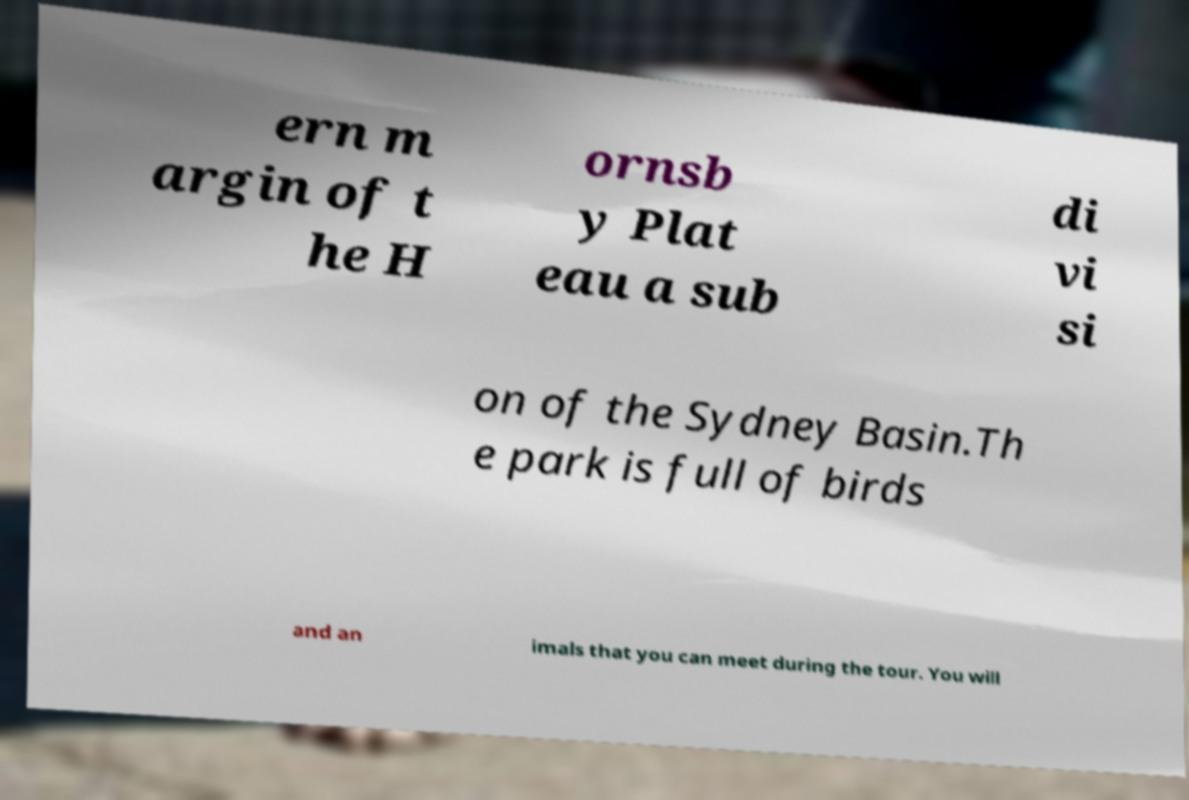There's text embedded in this image that I need extracted. Can you transcribe it verbatim? ern m argin of t he H ornsb y Plat eau a sub di vi si on of the Sydney Basin.Th e park is full of birds and an imals that you can meet during the tour. You will 